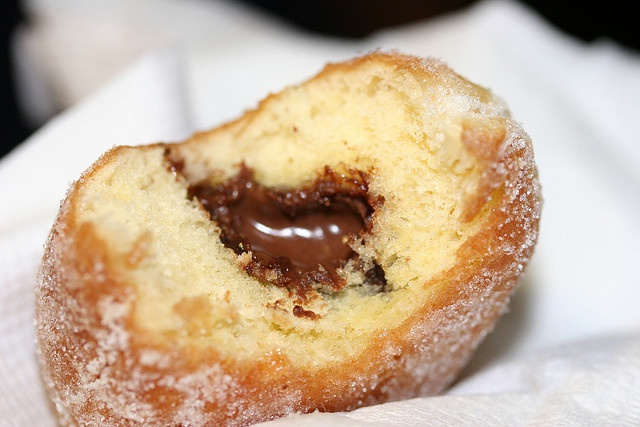Describe the objects in this image and their specific colors. I can see a donut in black, khaki, tan, and salmon tones in this image. 